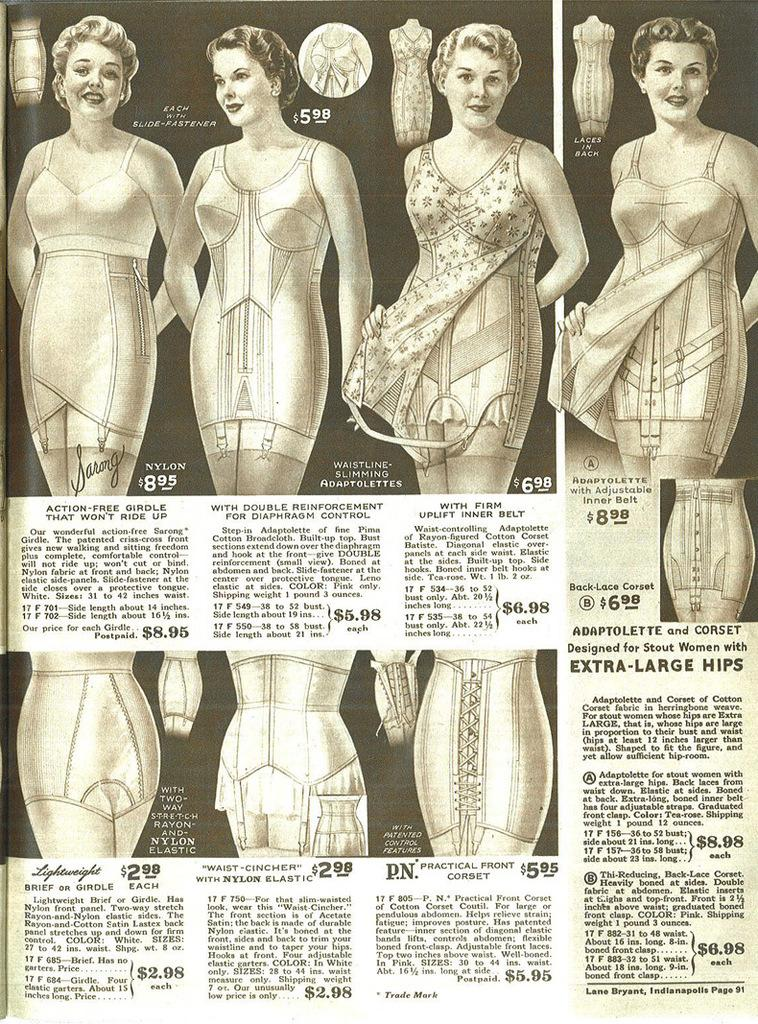What is the main object in the image? There is a newspaper in the image. What can be found within the newspaper? The newspaper contains images and paragraphs. What type of images are present in the newspaper? The images on the newspaper depict persons. How does the rabbit contribute to the quiet atmosphere in the image? There is no rabbit present in the image, so it cannot contribute to the atmosphere. 